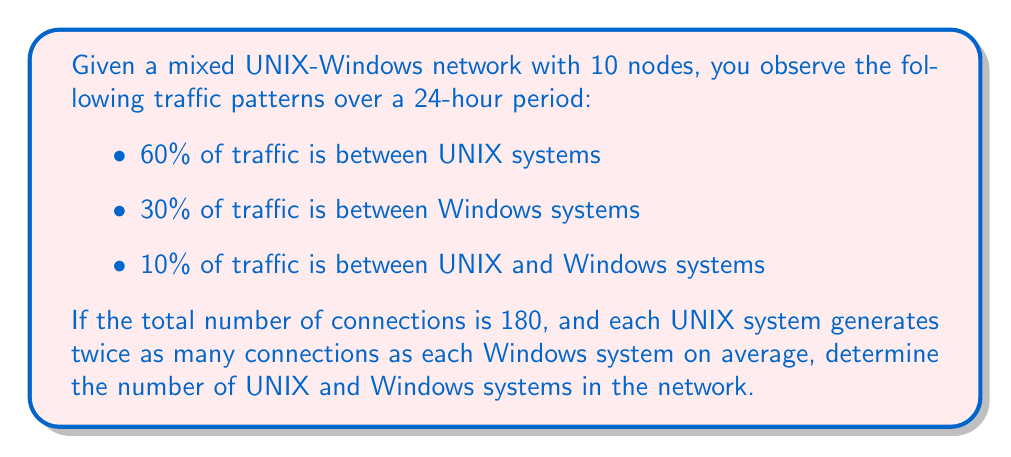Could you help me with this problem? Let's approach this step-by-step:

1) Let $x$ be the number of UNIX systems and $y$ be the number of Windows systems.
   We know that $x + y = 10$.

2) Let's define $c_u$ as the average number of connections per UNIX system and $c_w$ as the average number of connections per Windows system.
   We're told that $c_u = 2c_w$.

3) The total number of connections is 180. We can express this as:
   $xc_u + yc_w = 180$

4) Substituting $c_u = 2c_w$ into this equation:
   $x(2c_w) + yc_w = 180$
   $2xc_w + yc_w = 180$

5) Now, let's consider the traffic patterns:
   - UNIX to UNIX: $\frac{x(x-1)}{2} \cdot \frac{c_u}{2} = 0.6 \cdot 180 = 108$
   - Windows to Windows: $\frac{y(y-1)}{2} \cdot \frac{c_w}{2} = 0.3 \cdot 180 = 54$
   - UNIX to Windows: $xy \cdot \frac{c_u + c_w}{4} = 0.1 \cdot 180 = 18$

6) From the UNIX to UNIX equation:
   $\frac{x(x-1)}{2} \cdot c_w = 108$

7) From the Windows to Windows equation:
   $\frac{y(y-1)}{2} \cdot \frac{c_w}{2} = 54$

8) Dividing these equations:
   $\frac{x(x-1)}{y(y-1)} = 2$

9) Substituting $y = 10 - x$ and solving:
   $\frac{x(x-1)}{(10-x)(9-x)} = 2$
   $x^2 - x = 2(90 - 19x + x^2)$
   $x^2 - x = 180 - 38x + 2x^2$
   $x^2 - x = 180 - 38x + 2x^2$
   $-x^2 + 37x - 180 = 0$

10) Solving this quadratic equation:
    $x = 6$ or $x = 31$ (which we can discard as it's greater than 10)

Therefore, there are 6 UNIX systems and 4 Windows systems.
Answer: 6 UNIX systems, 4 Windows systems 